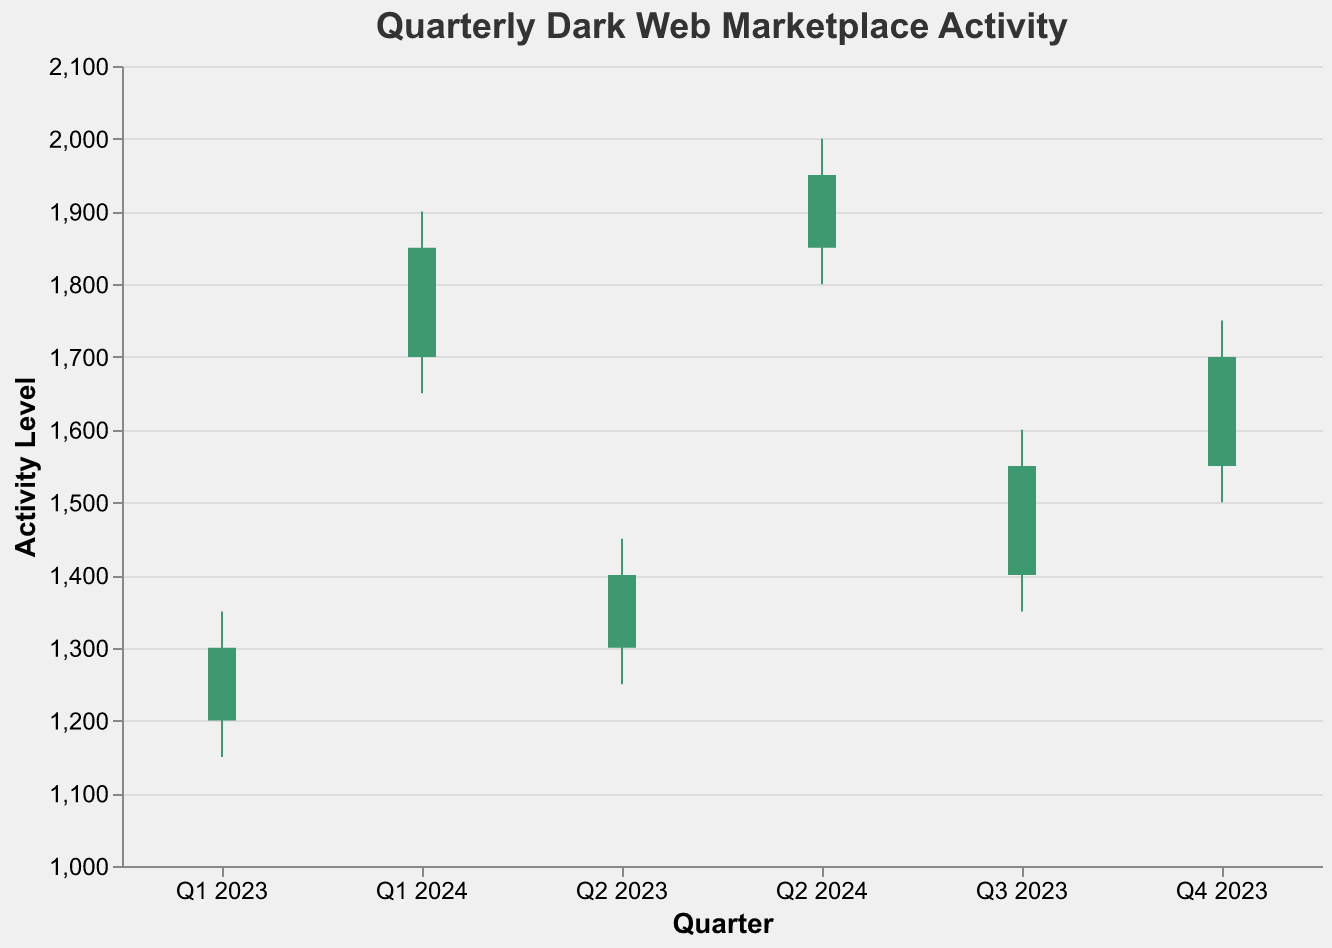What is the title of the figure? The title is displayed at the top of the chart and is "Quarterly Dark Web Marketplace Activity."
Answer: Quarterly Dark Web Marketplace Activity How many quarters are represented in the figure? The x-axis lists the quarters, and there are six distinct quarters shown (Q1 2023 to Q2 2024).
Answer: 6 What colors indicate an increase or decrease in activity? In the OHLC chart, green indicates an increase (Open < Close) and red indicates a decrease (Open > Close).
Answer: Green for increase, red for decrease Which quarter has the highest closing activity level? By examining the closing values on the y-axis, Q2 2024 has the highest closing activity level of 1950.
Answer: Q2 2024 What is the high value for Q1 2024? The high value for Q1 2024 is read directly from the data associated with Q1 2024, which is 1900.
Answer: 1900 How many active vendors were there in Q4 2023? The number of active vendors for Q4 2023 can be found in the data table and is 11000.
Answer: 11000 What was the range of activity for Q3 2023? The range is determined by subtracting the low value from the high value: 1600 - 1350 = 250.
Answer: 250 Which quarter had the smallest high to low range? By subtracting the low values from the high values for each quarter: Q1 2024 has the smallest range (1900 - 1650 = 250).
Answer: Q1 2024 Did the number of product listings increase in every quarter? By comparing the ProductListings column for each quarter, each quarter shows an increase from the previous quarter.
Answer: Yes What is the difference in active vendors between Q1 2023 and Q2 2024? Subtract the number of active vendors in Q1 2023 from Q2 2024: 12500 - 8500 = 4000.
Answer: 4000 Which quarter shows the highest volatility in activity levels? The highest volatility can be found by identifying the largest high-low range, which is Q4 2023 with (1750 - 1500 = 250).
Answer: Q4 2023 